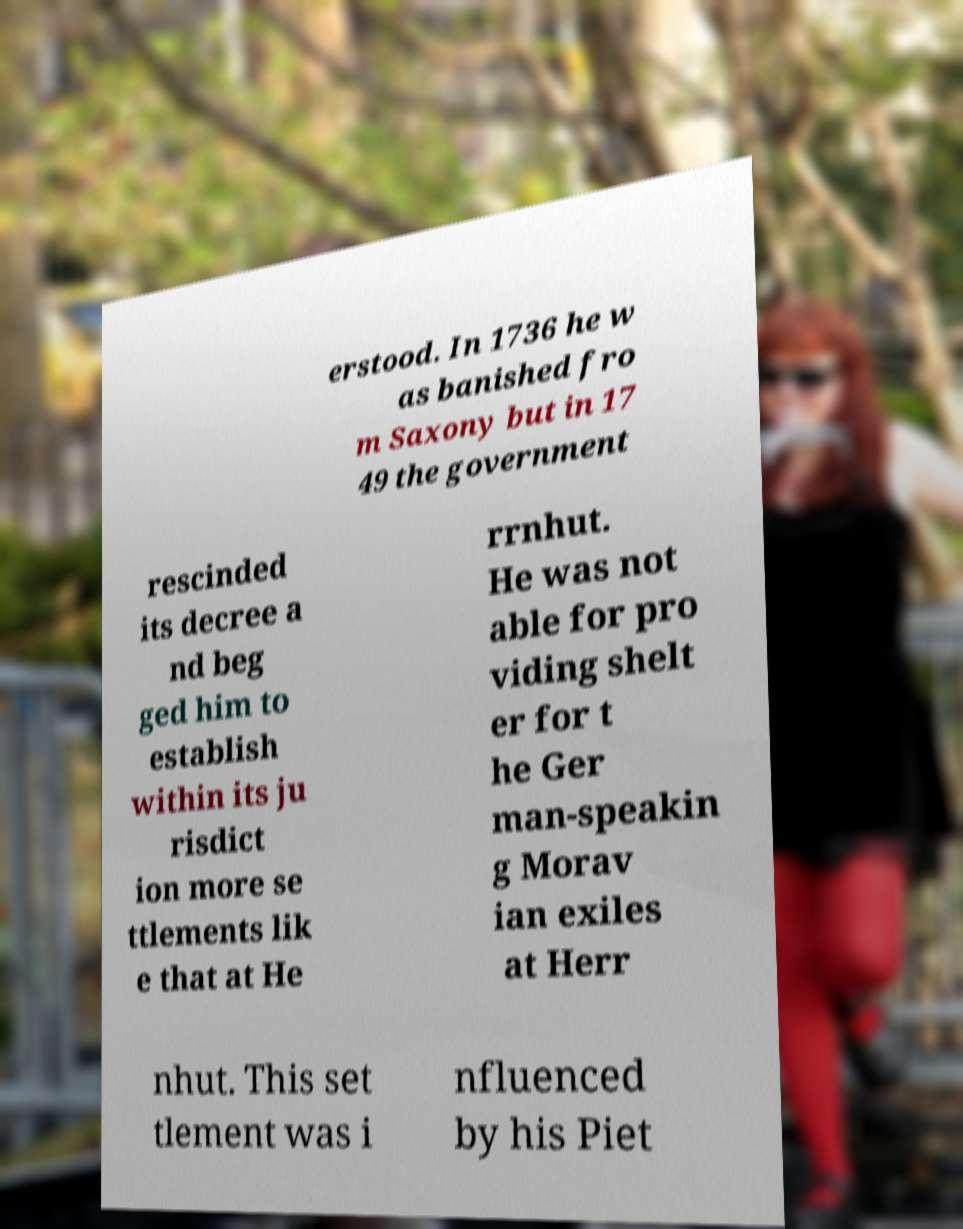Please read and relay the text visible in this image. What does it say? erstood. In 1736 he w as banished fro m Saxony but in 17 49 the government rescinded its decree a nd beg ged him to establish within its ju risdict ion more se ttlements lik e that at He rrnhut. He was not able for pro viding shelt er for t he Ger man-speakin g Morav ian exiles at Herr nhut. This set tlement was i nfluenced by his Piet 